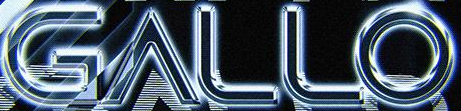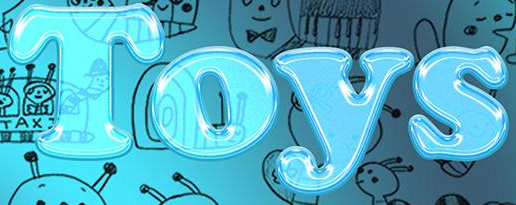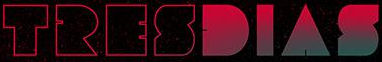What text is displayed in these images sequentially, separated by a semicolon? GALLO; Toys; TRESDIAS 